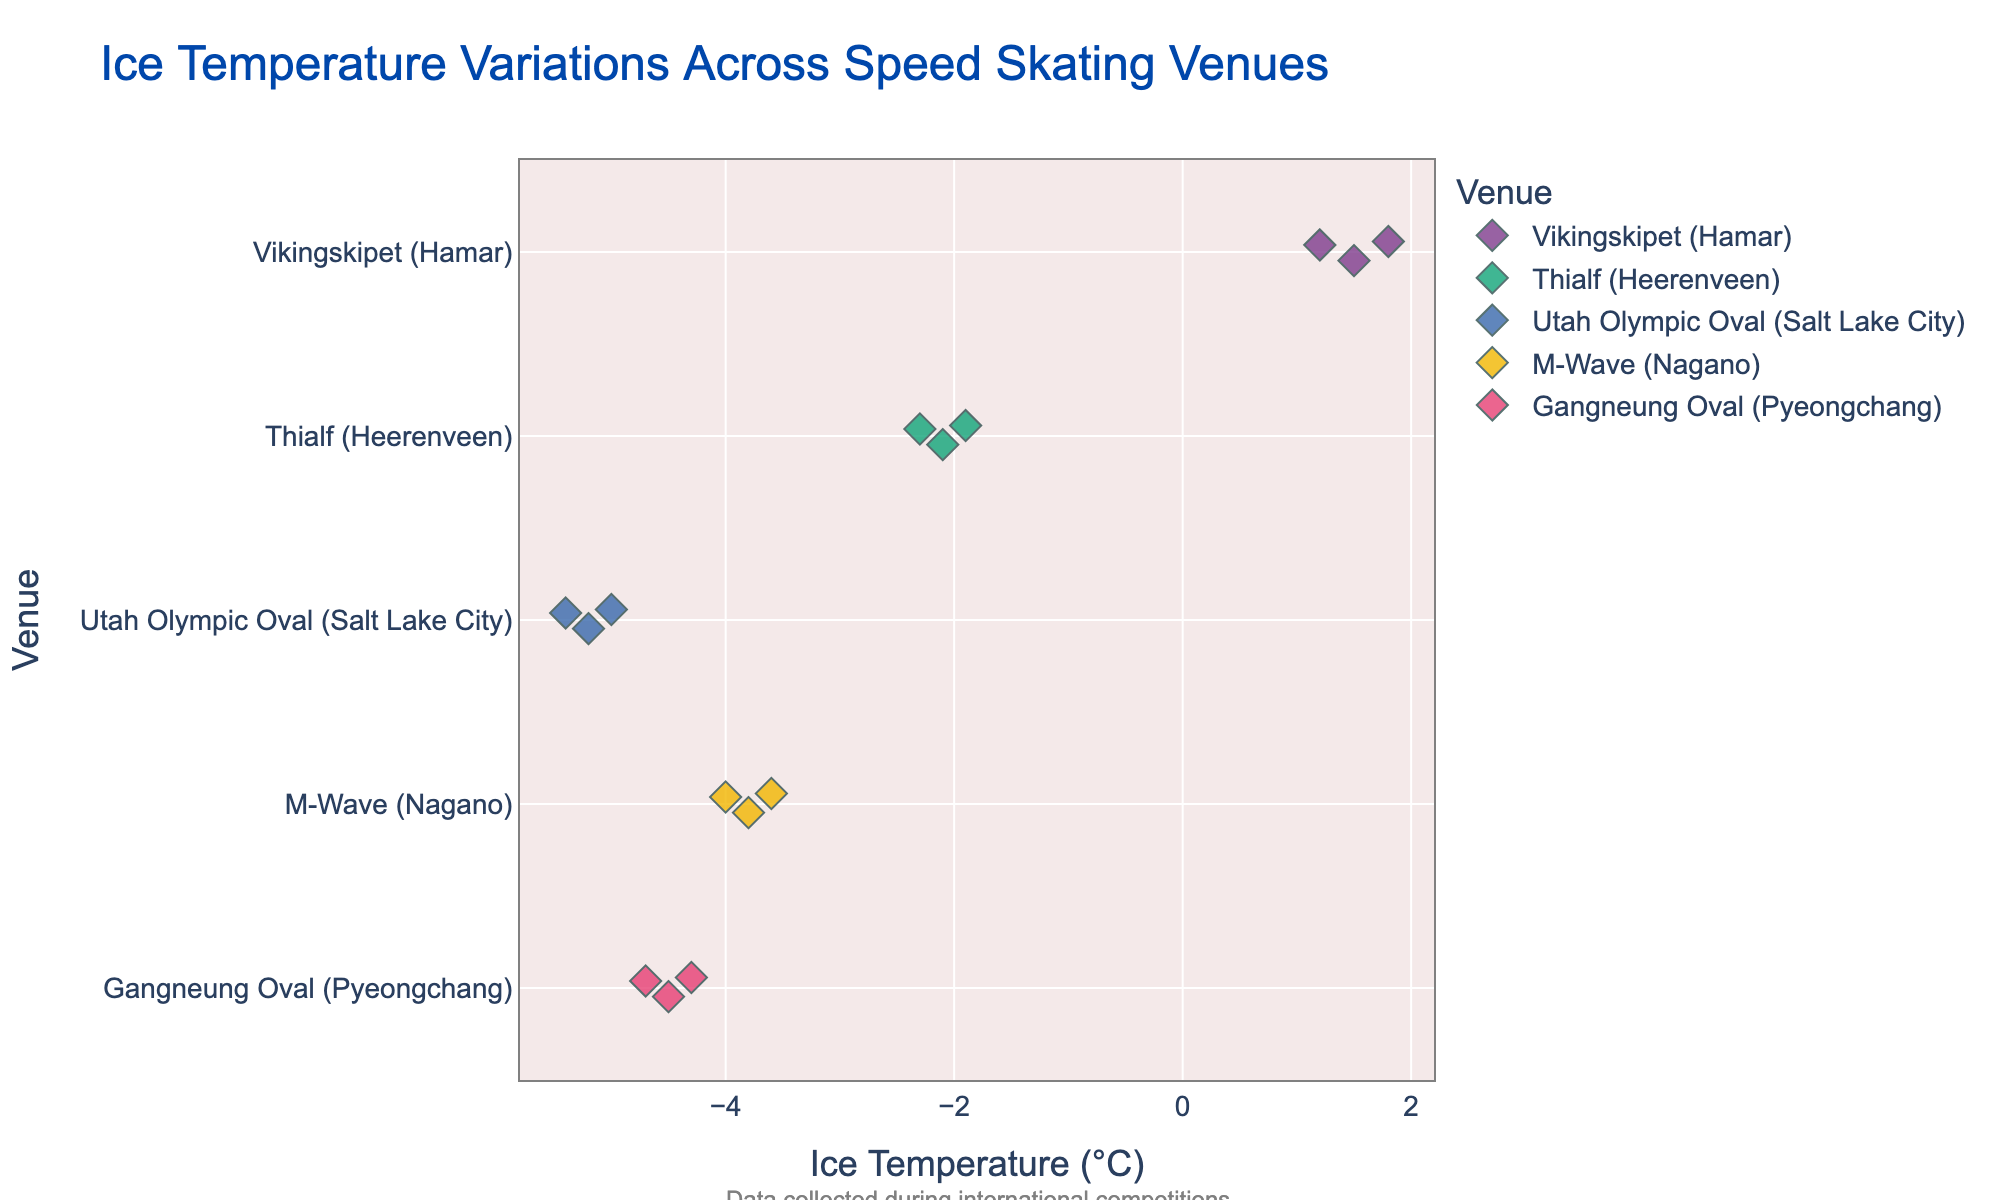What's the title of the strip plot? The title is provided at the top of the plot and is clearly visible. The title helps in understanding the context of the data visualized.
Answer: Ice Temperature Variations Across Speed Skating Venues What are the temperature ranges for Vikingskipet (Hamar)? Vikingskipet (Hamar) appears as a distinct category on the y-axis. By identifying the temperature points marked on the x-axis corresponding to Vikingskipet (Hamar), one can determine the range.
Answer: 1.2°C to 1.8°C Which venue has the lowest recorded temperature? Observe the temperature values on the x-axis and note which venue corresponds to the lowest value on the far left. This involves locating the point at the minimum x-axis value and reading its associated y-axis category.
Answer: Utah Olympic Oval (Salt Lake City) What's the average temperature of Thialf (Heerenveen)? Identify all temperature points for Thialf (Heerenveen) on the plot. Sum these values and divide by the number of data points to get the average. (-2.1 + -1.9 + -2.3) / 3 = -2.1
Answer: -2.1°C Compare the temperature ranges of M-Wave (Nagano) and Gangneung Oval (Pyeongchang). Which one has a wider range? First, determine the temperature ranges of both venues by identifying the minimum and maximum temperatures plotted. Then, calculate the range for each and compare them. M-Wave: -4.0°C - (-3.8) = 0.2°C Gangneung Oval: -4.7 - (-4.3) = 0.4°C
Answer: Gangneung Oval (Pyeongchang) What design elements reflect Norwegian pride in the plot? The figure contains a subtle background designed to resemble the Norwegian flag, likely red with a design, and annotations that may reflect the contextual importance of international competitions significant to Norwegians.
Answer: Norwegian flag-inspired background and caption emphasizing international competitions How many temperature data points are there for each venue? Count the number of temperature markers plotted for each venue on the y-axis. Vikingskipet (Hamar): 3, Thialf (Heerenveen): 3, Utah Olympic Oval (Salt Lake City): 3, M-Wave (Nagano): 3, Gangneung Oval (Pyeongchang): 3.
Answer: Each venue has 3 data points Which venue shows the most variation in temperatures? Compute the variance for each venue's temperature data. The venue with the largest variance has the most variation in temperatures. Visual estimation can sometimes be aided by the spread of points along the x-axis for each venue category.
Answer: Utah Olympic Oval (Salt Lake City) 